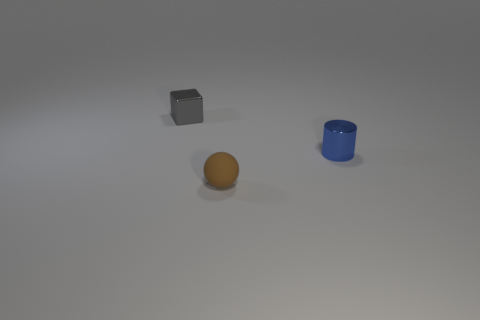Are there any other things that have the same material as the brown ball?
Your answer should be compact. No. There is a small sphere; are there any rubber balls behind it?
Make the answer very short. No. Are there more tiny rubber objects behind the tiny rubber sphere than tiny blue metallic cylinders on the left side of the tiny metal cube?
Offer a terse response. No. How many cylinders are either small brown things or cyan matte objects?
Ensure brevity in your answer.  0. Are there fewer brown spheres behind the blue metal object than tiny blocks that are on the right side of the sphere?
Your answer should be compact. No. What number of things are metallic objects that are to the right of the small metal block or big shiny cubes?
Provide a succinct answer. 1. What is the shape of the metal thing behind the shiny object that is in front of the tiny gray metal thing?
Offer a very short reply. Cube. Is there another brown sphere that has the same size as the ball?
Offer a terse response. No. Is the number of cylinders greater than the number of large blue rubber balls?
Give a very brief answer. Yes. There is a thing to the right of the brown ball; is its size the same as the metal thing that is behind the blue cylinder?
Keep it short and to the point. Yes. 